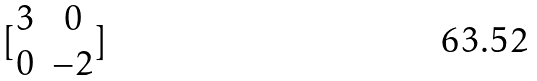Convert formula to latex. <formula><loc_0><loc_0><loc_500><loc_500>[ \begin{matrix} 3 & 0 \\ 0 & - 2 \end{matrix} ]</formula> 